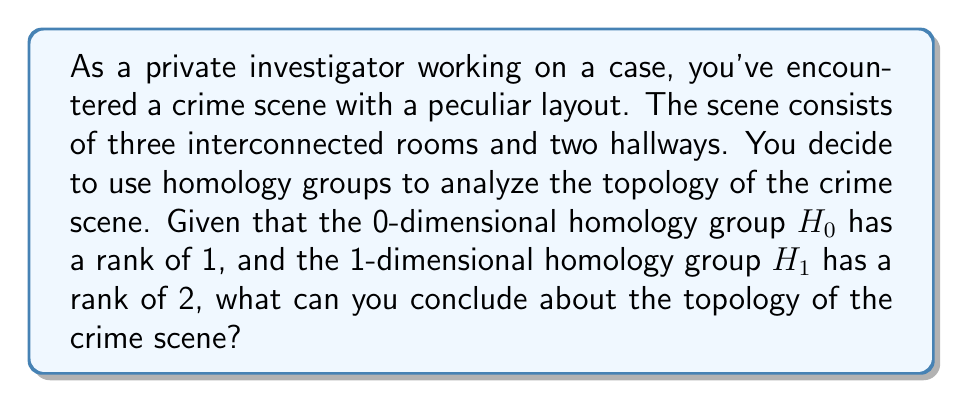Solve this math problem. To analyze this problem, let's break it down step-by-step using homology theory:

1. Understanding homology groups:
   - $H_0$ represents the number of connected components
   - $H_1$ represents the number of 1-dimensional holes or loops

2. Given information:
   - rank($H_0$) = 1
   - rank($H_1$) = 2

3. Interpreting $H_0$:
   - rank($H_0$) = 1 means there is only one connected component
   - This implies that all rooms and hallways are interconnected

4. Interpreting $H_1$:
   - rank($H_1$) = 2 means there are two 1-dimensional holes or loops in the structure

5. Visualizing the topology:
   - Three rooms connected by two hallways can form two loops
   - One possible configuration is a triangular arrangement of rooms with hallways connecting them

6. Topological equivalence:
   - This crime scene layout is topologically equivalent to a torus (donut shape)
   - A torus has one connected component and two independent loops (one around the hole and one around the body of the donut)

7. Crime scene implications:
   - The layout allows for multiple paths between rooms
   - There are no isolated areas within the crime scene

The homology groups provide crucial information about the connectivity and structure of the crime scene, which can be valuable for understanding potential escape routes or hidden areas.
Answer: The crime scene is topologically equivalent to a torus, with one connected component and two independent loops. This implies a layout where all rooms and hallways are interconnected, forming two distinct circular paths within the structure. 